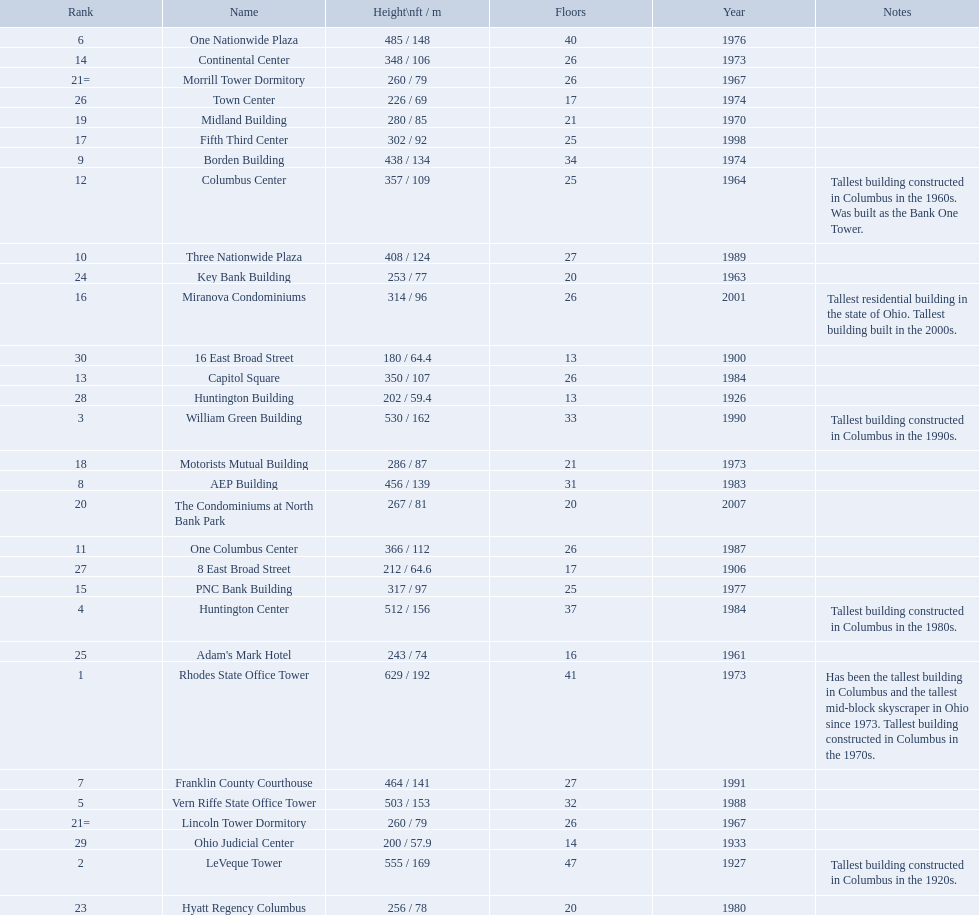How tall is the aep building? 456 / 139. How tall is the one columbus center? 366 / 112. Of these two buildings, which is taller? AEP Building. 